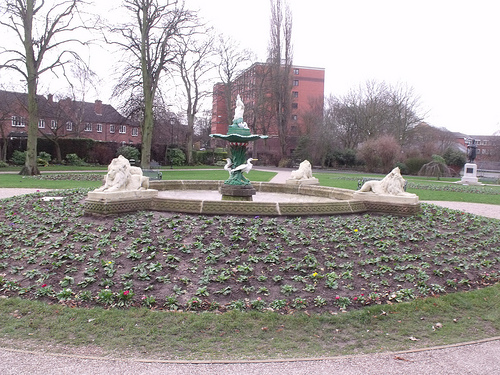<image>
Is the statue next to the building? No. The statue is not positioned next to the building. They are located in different areas of the scene. 